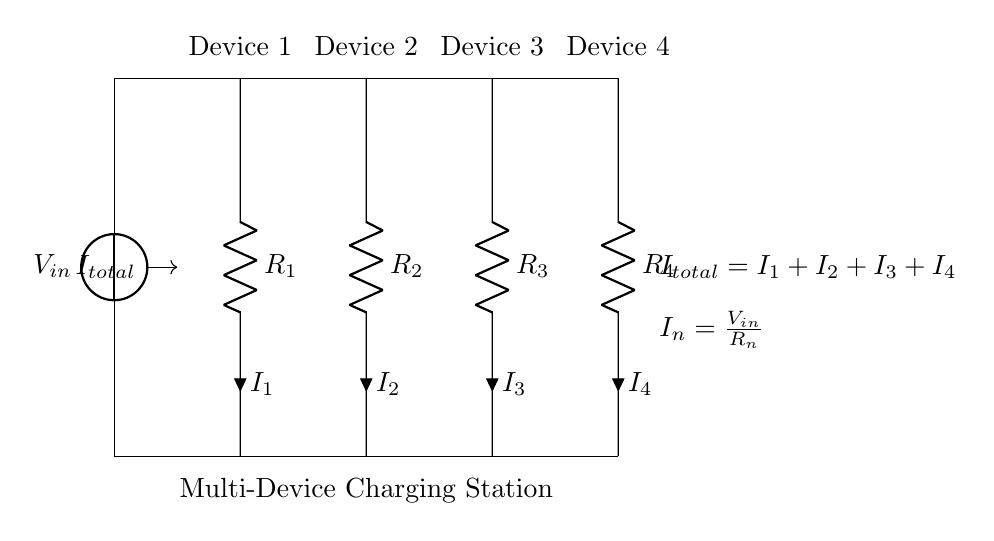What is the input voltage of the circuit? The input voltage is labeled as V_in in the diagram, which is indicated directly next to the voltage source symbol.
Answer: V_in What is the total current flowing through the circuit? The total current, I_total, is expressed as the sum of the individual currents I_1, I_2, I_3, and I_4, which are the currents through each resistor in the parallel configuration. This is shown in the circuit with the formula I_total = I_1 + I_2 + I_3 + I_4 labeled near the connection point.
Answer: I_1 + I_2 + I_3 + I_4 What is the relationship between voltage and resistance for each device? Each device has a resistor (R_n) connected to it, with the current flowing through it denoted by I_n. The relationship is given by Ohm's law, where the voltage across each resistor is determined by the current and resistance in the formula I_n = V_in / R_n, pointed out near the devices in the diagram.
Answer: I_n = V_in / R_n How many devices are connected to the power source? The circuit diagram shows four vertical resistors, each labeled as R_1, R_2, R_3, and R_4, corresponding to four devices, which indicates that there are four devices connected to the power source in parallel.
Answer: Four Which resistor is connected to Device 3? The resistor connected to Device 3 is labeled as R_3 in the diagram, which can be identified by its position in the sequence of connected resistors from left to right.
Answer: R_3 What happens to the total current if one device is disconnected? Disconnecting one device will reduce the total current because the remaining devices will still carry their individual currents. Their currents will combine according to the current divider rule, thus the total current will be less than it was with all devices connected, demonstrating a direct impact on I_total when any single current path is removed.
Answer: Decreases 